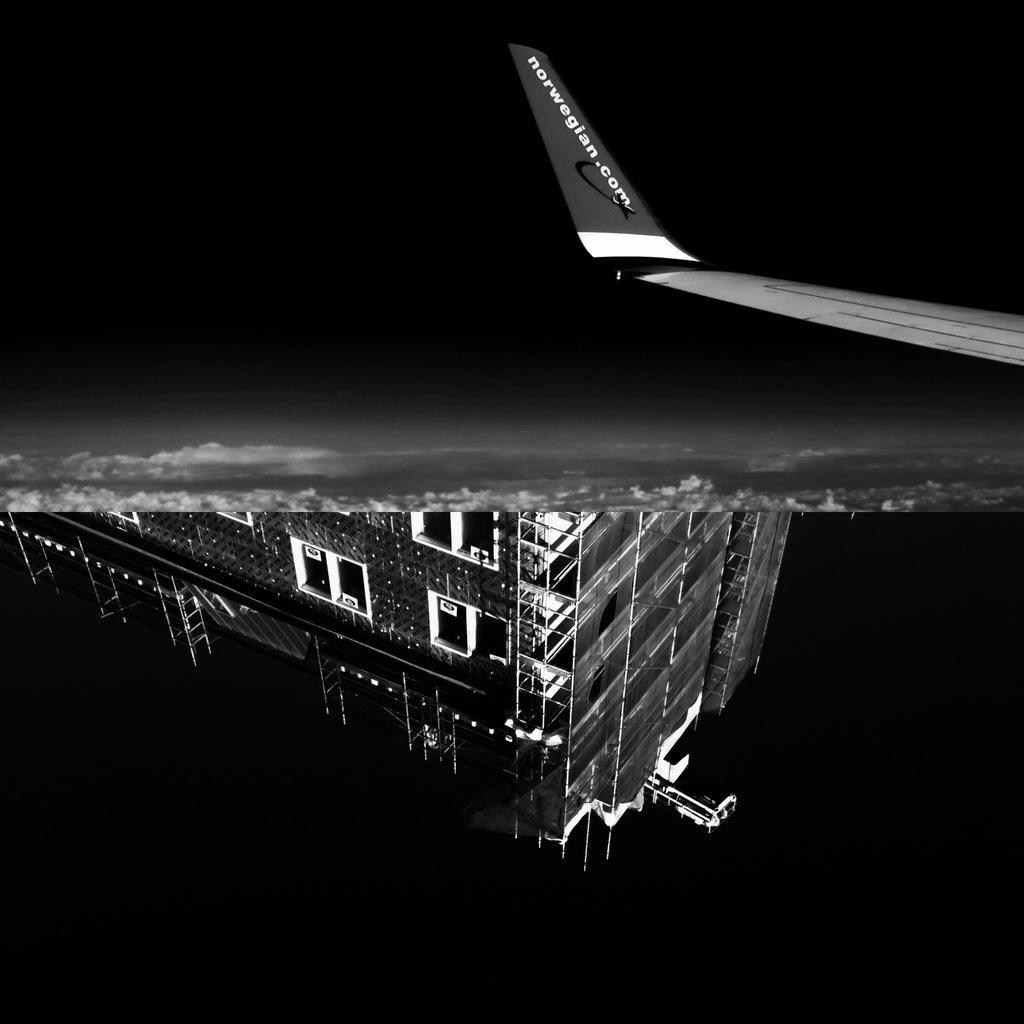Could you give a brief overview of what you see in this image? This is a black and white image. It is edited and made collage. In this image I can see two pictures. In the top picture I can see an aeroplane and clouds. In the bottom image I can see a building along with the windows. 